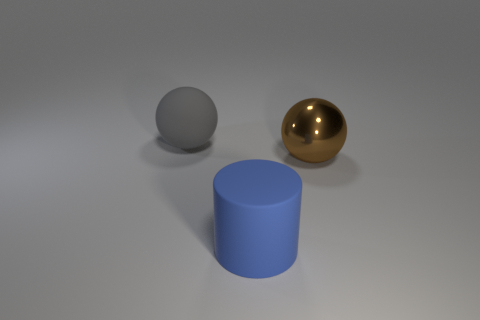Add 3 big blue rubber objects. How many objects exist? 6 Subtract all cylinders. How many objects are left? 2 Subtract all big brown metal balls. Subtract all large brown metallic things. How many objects are left? 1 Add 1 shiny spheres. How many shiny spheres are left? 2 Add 1 yellow cylinders. How many yellow cylinders exist? 1 Subtract 0 brown cylinders. How many objects are left? 3 Subtract 2 spheres. How many spheres are left? 0 Subtract all yellow balls. Subtract all blue cylinders. How many balls are left? 2 Subtract all gray cylinders. How many yellow spheres are left? 0 